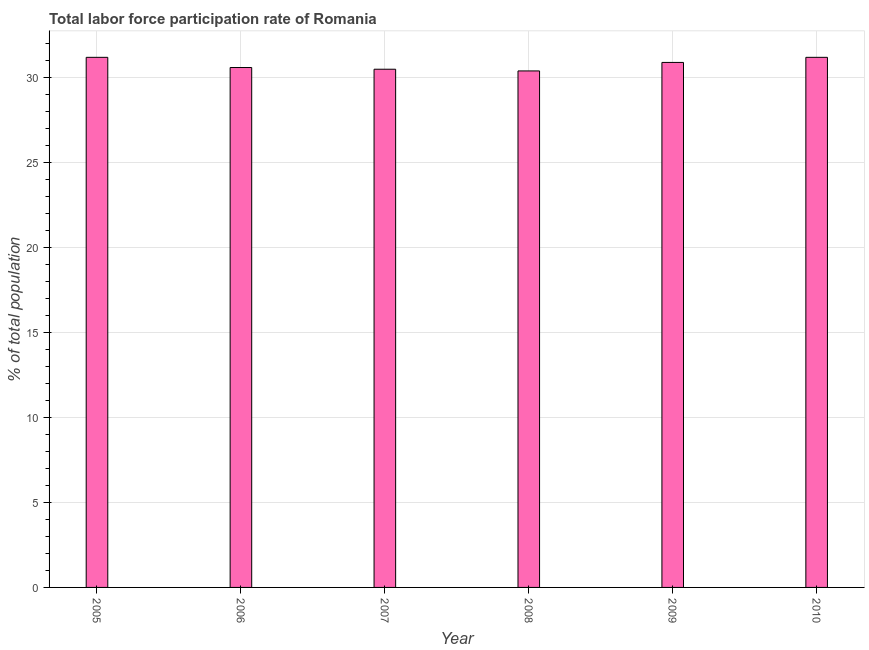What is the title of the graph?
Your answer should be compact. Total labor force participation rate of Romania. What is the label or title of the X-axis?
Ensure brevity in your answer.  Year. What is the label or title of the Y-axis?
Provide a short and direct response. % of total population. What is the total labor force participation rate in 2010?
Make the answer very short. 31.2. Across all years, what is the maximum total labor force participation rate?
Ensure brevity in your answer.  31.2. Across all years, what is the minimum total labor force participation rate?
Your answer should be compact. 30.4. In which year was the total labor force participation rate maximum?
Your answer should be very brief. 2005. What is the sum of the total labor force participation rate?
Offer a terse response. 184.8. What is the difference between the total labor force participation rate in 2007 and 2009?
Offer a very short reply. -0.4. What is the average total labor force participation rate per year?
Make the answer very short. 30.8. What is the median total labor force participation rate?
Keep it short and to the point. 30.75. In how many years, is the total labor force participation rate greater than 2 %?
Your response must be concise. 6. Do a majority of the years between 2009 and 2010 (inclusive) have total labor force participation rate greater than 22 %?
Your answer should be compact. Yes. What is the ratio of the total labor force participation rate in 2006 to that in 2009?
Offer a very short reply. 0.99. Is the total labor force participation rate in 2005 less than that in 2009?
Your answer should be very brief. No. Is the sum of the total labor force participation rate in 2006 and 2010 greater than the maximum total labor force participation rate across all years?
Keep it short and to the point. Yes. In how many years, is the total labor force participation rate greater than the average total labor force participation rate taken over all years?
Ensure brevity in your answer.  3. How many years are there in the graph?
Your answer should be very brief. 6. What is the % of total population in 2005?
Give a very brief answer. 31.2. What is the % of total population in 2006?
Give a very brief answer. 30.6. What is the % of total population in 2007?
Your response must be concise. 30.5. What is the % of total population in 2008?
Offer a very short reply. 30.4. What is the % of total population in 2009?
Your answer should be compact. 30.9. What is the % of total population in 2010?
Ensure brevity in your answer.  31.2. What is the difference between the % of total population in 2005 and 2006?
Make the answer very short. 0.6. What is the difference between the % of total population in 2005 and 2009?
Your answer should be very brief. 0.3. What is the difference between the % of total population in 2005 and 2010?
Make the answer very short. 0. What is the difference between the % of total population in 2006 and 2007?
Keep it short and to the point. 0.1. What is the difference between the % of total population in 2006 and 2010?
Make the answer very short. -0.6. What is the difference between the % of total population in 2007 and 2009?
Your answer should be compact. -0.4. What is the difference between the % of total population in 2007 and 2010?
Your answer should be compact. -0.7. What is the difference between the % of total population in 2008 and 2009?
Provide a short and direct response. -0.5. What is the ratio of the % of total population in 2005 to that in 2009?
Keep it short and to the point. 1.01. What is the ratio of the % of total population in 2006 to that in 2007?
Offer a terse response. 1. What is the ratio of the % of total population in 2006 to that in 2008?
Your answer should be very brief. 1.01. What is the ratio of the % of total population in 2006 to that in 2009?
Make the answer very short. 0.99. What is the ratio of the % of total population in 2006 to that in 2010?
Provide a short and direct response. 0.98. What is the ratio of the % of total population in 2007 to that in 2009?
Your answer should be very brief. 0.99. What is the ratio of the % of total population in 2007 to that in 2010?
Offer a terse response. 0.98. What is the ratio of the % of total population in 2009 to that in 2010?
Offer a terse response. 0.99. 